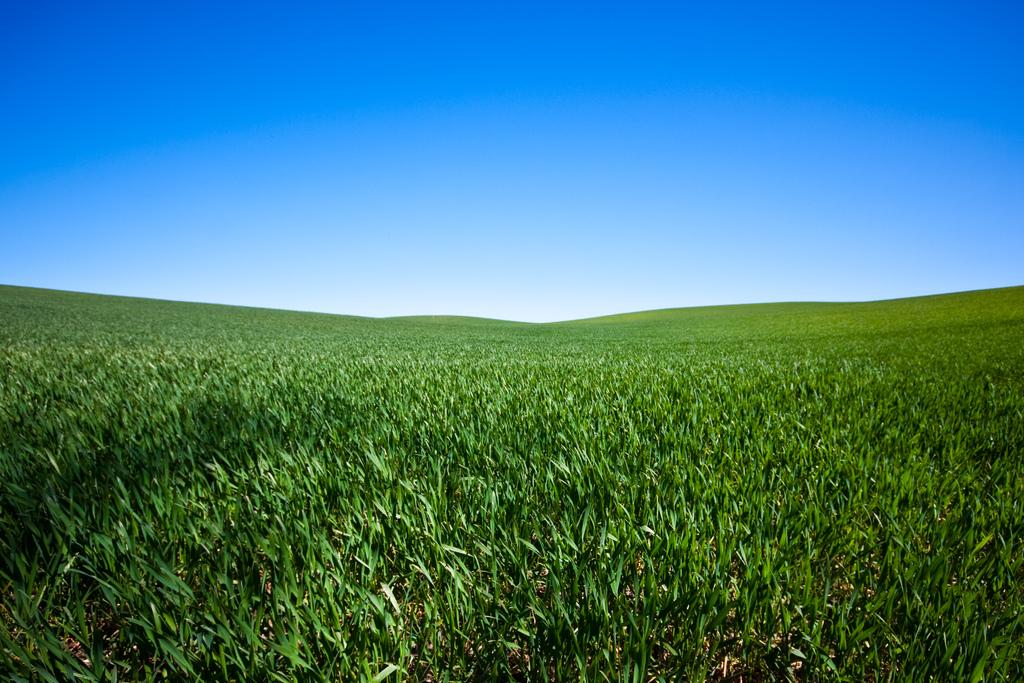What type of vegetation is present at the bottom of the image? There are plants at the bottom of the image. What part of the natural environment is visible at the top of the image? The sky is visible at the top of the image. What type of locket can be seen hanging from the toe of the person in the image? There is no person or locket present in the image; it only features plants and the sky. 